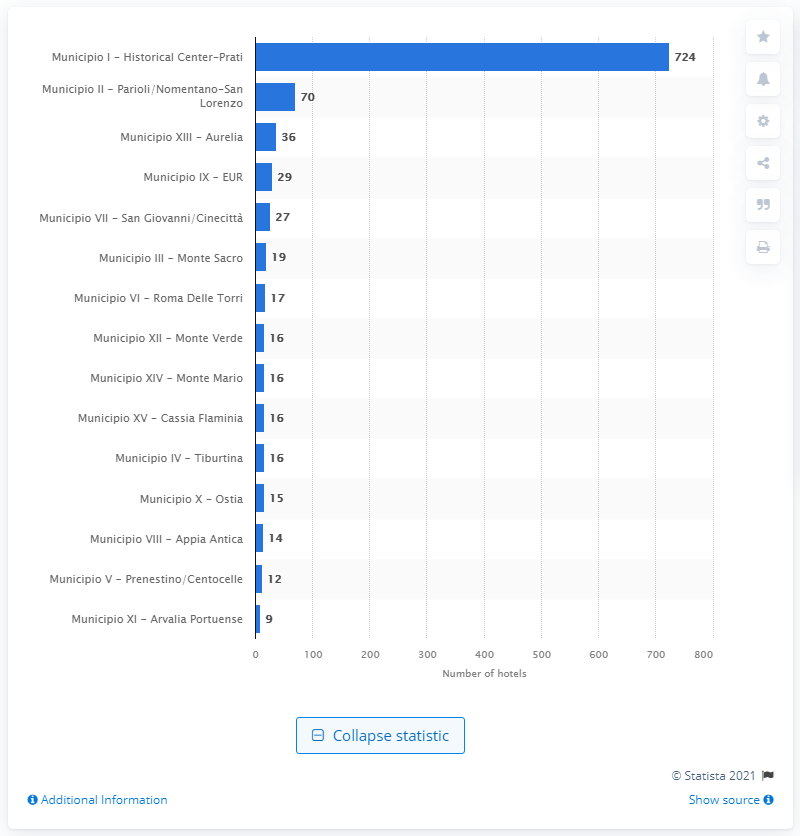Mention a couple of crucial points in this snapshot. In 2019, the Municipio I - Historical Center - Prati had a total of 724 hotels. 